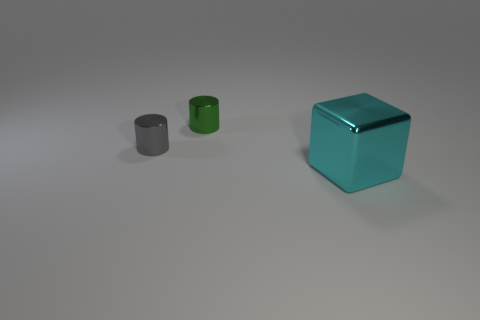The thing that is behind the big cyan block and to the right of the small gray thing is made of what material?
Ensure brevity in your answer.  Metal. What number of large blue things have the same shape as the gray shiny object?
Ensure brevity in your answer.  0. There is a shiny cylinder that is in front of the metallic cylinder behind the gray shiny cylinder; how big is it?
Keep it short and to the point. Small. Do the tiny metallic cylinder to the left of the green metallic thing and the metal object on the right side of the green metal cylinder have the same color?
Provide a short and direct response. No. What number of small gray things are in front of the small thing that is in front of the small shiny thing to the right of the gray cylinder?
Make the answer very short. 0. What number of objects are to the left of the cyan shiny thing and in front of the green object?
Provide a succinct answer. 1. Is the number of metal cubes left of the tiny green object greater than the number of small gray objects?
Offer a terse response. No. How many other metal cubes are the same size as the cyan shiny cube?
Ensure brevity in your answer.  0. What number of large things are blue rubber objects or cyan metallic things?
Offer a terse response. 1. How many big cyan metal blocks are there?
Ensure brevity in your answer.  1. 